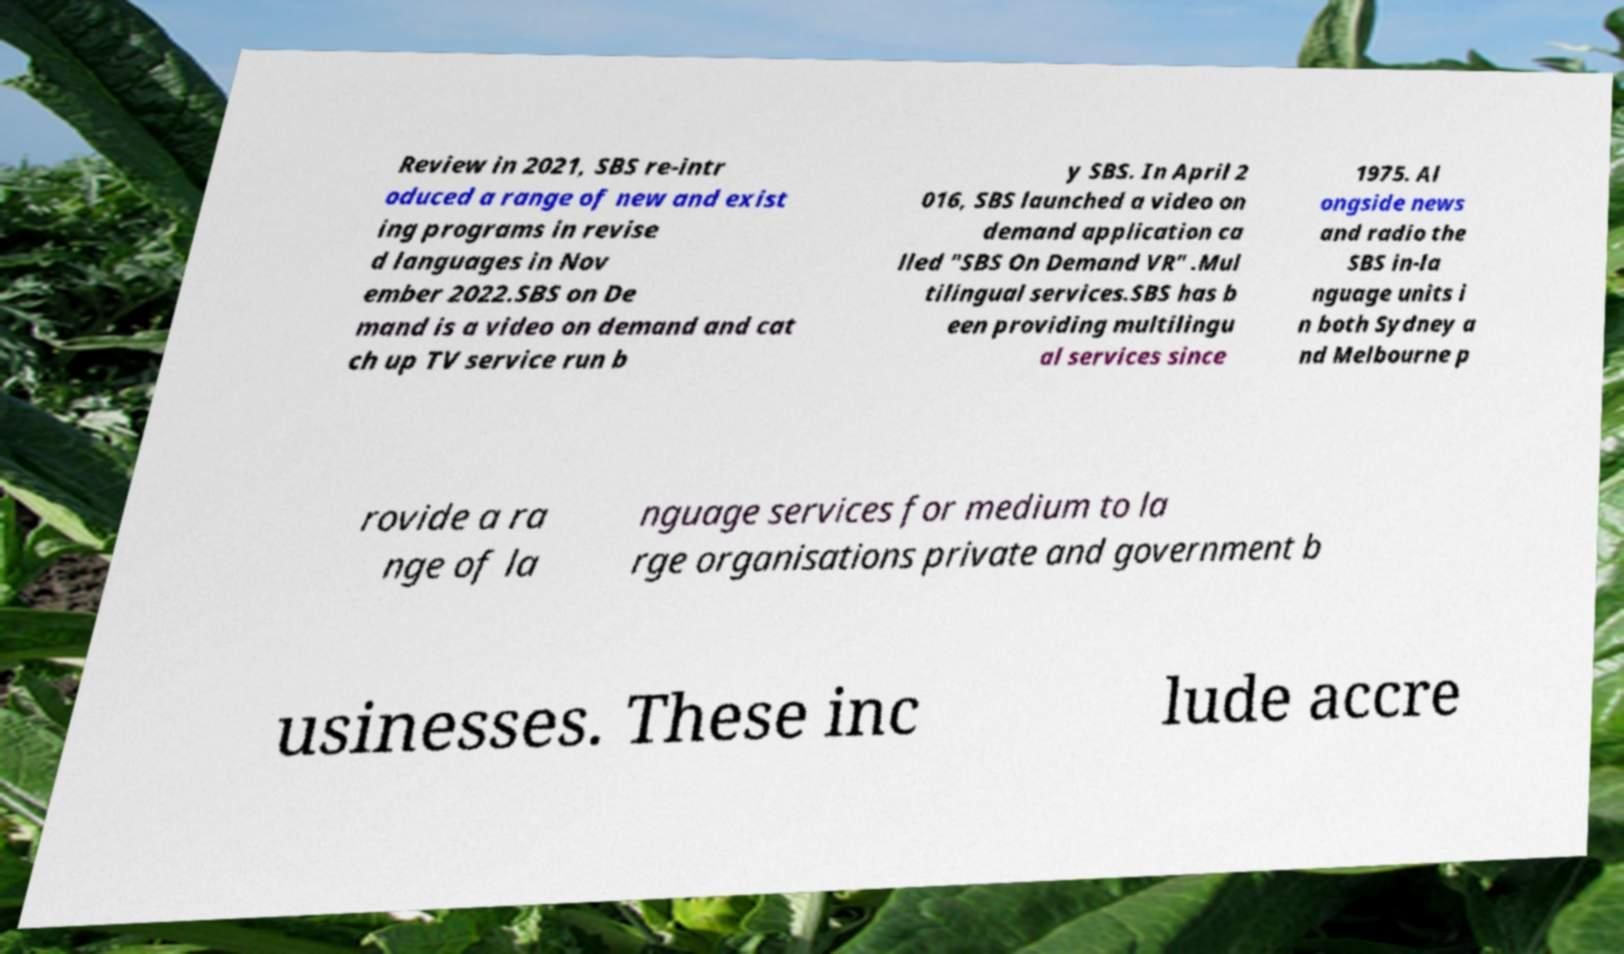What messages or text are displayed in this image? I need them in a readable, typed format. Review in 2021, SBS re-intr oduced a range of new and exist ing programs in revise d languages in Nov ember 2022.SBS on De mand is a video on demand and cat ch up TV service run b y SBS. In April 2 016, SBS launched a video on demand application ca lled "SBS On Demand VR" .Mul tilingual services.SBS has b een providing multilingu al services since 1975. Al ongside news and radio the SBS in-la nguage units i n both Sydney a nd Melbourne p rovide a ra nge of la nguage services for medium to la rge organisations private and government b usinesses. These inc lude accre 